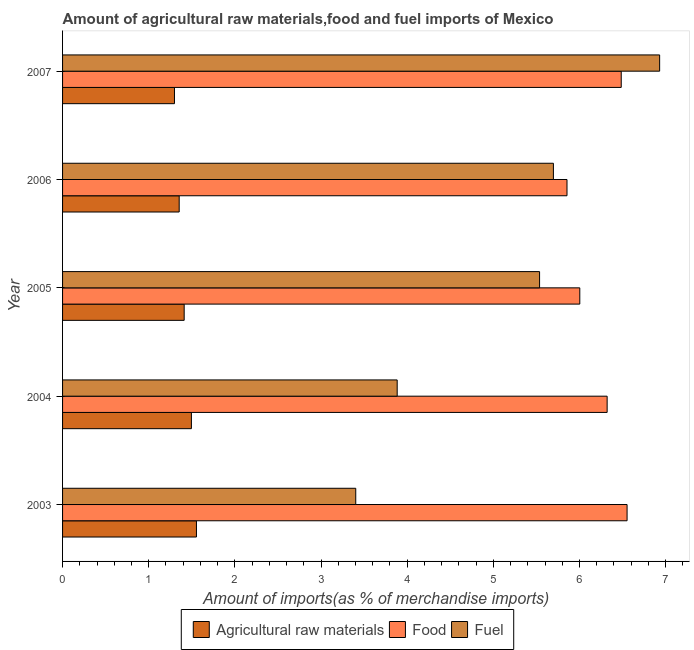How many different coloured bars are there?
Provide a succinct answer. 3. Are the number of bars per tick equal to the number of legend labels?
Provide a short and direct response. Yes. Are the number of bars on each tick of the Y-axis equal?
Give a very brief answer. Yes. What is the label of the 3rd group of bars from the top?
Your response must be concise. 2005. What is the percentage of raw materials imports in 2006?
Provide a succinct answer. 1.35. Across all years, what is the maximum percentage of food imports?
Provide a succinct answer. 6.55. Across all years, what is the minimum percentage of raw materials imports?
Offer a very short reply. 1.3. In which year was the percentage of food imports minimum?
Keep it short and to the point. 2006. What is the total percentage of raw materials imports in the graph?
Your response must be concise. 7.11. What is the difference between the percentage of food imports in 2003 and that in 2006?
Keep it short and to the point. 0.7. What is the difference between the percentage of fuel imports in 2003 and the percentage of food imports in 2005?
Make the answer very short. -2.6. What is the average percentage of raw materials imports per year?
Ensure brevity in your answer.  1.42. In the year 2004, what is the difference between the percentage of fuel imports and percentage of food imports?
Provide a short and direct response. -2.44. What is the ratio of the percentage of fuel imports in 2006 to that in 2007?
Your answer should be very brief. 0.82. Is the percentage of food imports in 2004 less than that in 2006?
Provide a succinct answer. No. Is the difference between the percentage of raw materials imports in 2004 and 2005 greater than the difference between the percentage of fuel imports in 2004 and 2005?
Your response must be concise. Yes. What is the difference between the highest and the second highest percentage of food imports?
Make the answer very short. 0.07. What is the difference between the highest and the lowest percentage of raw materials imports?
Make the answer very short. 0.26. In how many years, is the percentage of fuel imports greater than the average percentage of fuel imports taken over all years?
Your answer should be very brief. 3. Is the sum of the percentage of raw materials imports in 2003 and 2007 greater than the maximum percentage of food imports across all years?
Your answer should be very brief. No. What does the 3rd bar from the top in 2007 represents?
Provide a short and direct response. Agricultural raw materials. What does the 3rd bar from the bottom in 2004 represents?
Provide a short and direct response. Fuel. Are all the bars in the graph horizontal?
Keep it short and to the point. Yes. How many years are there in the graph?
Provide a succinct answer. 5. Does the graph contain any zero values?
Make the answer very short. No. Does the graph contain grids?
Provide a succinct answer. No. How many legend labels are there?
Your answer should be very brief. 3. How are the legend labels stacked?
Make the answer very short. Horizontal. What is the title of the graph?
Provide a succinct answer. Amount of agricultural raw materials,food and fuel imports of Mexico. What is the label or title of the X-axis?
Offer a very short reply. Amount of imports(as % of merchandise imports). What is the Amount of imports(as % of merchandise imports) in Agricultural raw materials in 2003?
Ensure brevity in your answer.  1.55. What is the Amount of imports(as % of merchandise imports) of Food in 2003?
Offer a very short reply. 6.55. What is the Amount of imports(as % of merchandise imports) of Fuel in 2003?
Provide a short and direct response. 3.4. What is the Amount of imports(as % of merchandise imports) in Agricultural raw materials in 2004?
Ensure brevity in your answer.  1.5. What is the Amount of imports(as % of merchandise imports) of Food in 2004?
Make the answer very short. 6.32. What is the Amount of imports(as % of merchandise imports) of Fuel in 2004?
Your answer should be very brief. 3.88. What is the Amount of imports(as % of merchandise imports) in Agricultural raw materials in 2005?
Ensure brevity in your answer.  1.41. What is the Amount of imports(as % of merchandise imports) of Food in 2005?
Keep it short and to the point. 6. What is the Amount of imports(as % of merchandise imports) of Fuel in 2005?
Your response must be concise. 5.54. What is the Amount of imports(as % of merchandise imports) of Agricultural raw materials in 2006?
Give a very brief answer. 1.35. What is the Amount of imports(as % of merchandise imports) in Food in 2006?
Ensure brevity in your answer.  5.86. What is the Amount of imports(as % of merchandise imports) in Fuel in 2006?
Provide a short and direct response. 5.7. What is the Amount of imports(as % of merchandise imports) in Agricultural raw materials in 2007?
Your answer should be very brief. 1.3. What is the Amount of imports(as % of merchandise imports) of Food in 2007?
Provide a short and direct response. 6.48. What is the Amount of imports(as % of merchandise imports) of Fuel in 2007?
Give a very brief answer. 6.93. Across all years, what is the maximum Amount of imports(as % of merchandise imports) of Agricultural raw materials?
Your answer should be very brief. 1.55. Across all years, what is the maximum Amount of imports(as % of merchandise imports) in Food?
Ensure brevity in your answer.  6.55. Across all years, what is the maximum Amount of imports(as % of merchandise imports) in Fuel?
Provide a succinct answer. 6.93. Across all years, what is the minimum Amount of imports(as % of merchandise imports) in Agricultural raw materials?
Provide a succinct answer. 1.3. Across all years, what is the minimum Amount of imports(as % of merchandise imports) of Food?
Provide a succinct answer. 5.86. Across all years, what is the minimum Amount of imports(as % of merchandise imports) of Fuel?
Your response must be concise. 3.4. What is the total Amount of imports(as % of merchandise imports) in Agricultural raw materials in the graph?
Give a very brief answer. 7.11. What is the total Amount of imports(as % of merchandise imports) of Food in the graph?
Your answer should be very brief. 31.22. What is the total Amount of imports(as % of merchandise imports) in Fuel in the graph?
Give a very brief answer. 25.45. What is the difference between the Amount of imports(as % of merchandise imports) of Agricultural raw materials in 2003 and that in 2004?
Your response must be concise. 0.06. What is the difference between the Amount of imports(as % of merchandise imports) of Food in 2003 and that in 2004?
Provide a succinct answer. 0.23. What is the difference between the Amount of imports(as % of merchandise imports) of Fuel in 2003 and that in 2004?
Offer a terse response. -0.48. What is the difference between the Amount of imports(as % of merchandise imports) in Agricultural raw materials in 2003 and that in 2005?
Your response must be concise. 0.14. What is the difference between the Amount of imports(as % of merchandise imports) in Food in 2003 and that in 2005?
Provide a succinct answer. 0.55. What is the difference between the Amount of imports(as % of merchandise imports) in Fuel in 2003 and that in 2005?
Your response must be concise. -2.13. What is the difference between the Amount of imports(as % of merchandise imports) in Agricultural raw materials in 2003 and that in 2006?
Give a very brief answer. 0.2. What is the difference between the Amount of imports(as % of merchandise imports) in Food in 2003 and that in 2006?
Make the answer very short. 0.7. What is the difference between the Amount of imports(as % of merchandise imports) of Fuel in 2003 and that in 2006?
Provide a short and direct response. -2.29. What is the difference between the Amount of imports(as % of merchandise imports) in Agricultural raw materials in 2003 and that in 2007?
Ensure brevity in your answer.  0.26. What is the difference between the Amount of imports(as % of merchandise imports) of Food in 2003 and that in 2007?
Your answer should be compact. 0.07. What is the difference between the Amount of imports(as % of merchandise imports) of Fuel in 2003 and that in 2007?
Keep it short and to the point. -3.53. What is the difference between the Amount of imports(as % of merchandise imports) of Agricultural raw materials in 2004 and that in 2005?
Your answer should be compact. 0.08. What is the difference between the Amount of imports(as % of merchandise imports) in Food in 2004 and that in 2005?
Offer a terse response. 0.32. What is the difference between the Amount of imports(as % of merchandise imports) of Fuel in 2004 and that in 2005?
Make the answer very short. -1.65. What is the difference between the Amount of imports(as % of merchandise imports) of Agricultural raw materials in 2004 and that in 2006?
Give a very brief answer. 0.14. What is the difference between the Amount of imports(as % of merchandise imports) in Food in 2004 and that in 2006?
Your response must be concise. 0.47. What is the difference between the Amount of imports(as % of merchandise imports) in Fuel in 2004 and that in 2006?
Give a very brief answer. -1.81. What is the difference between the Amount of imports(as % of merchandise imports) in Agricultural raw materials in 2004 and that in 2007?
Offer a terse response. 0.2. What is the difference between the Amount of imports(as % of merchandise imports) in Food in 2004 and that in 2007?
Ensure brevity in your answer.  -0.16. What is the difference between the Amount of imports(as % of merchandise imports) in Fuel in 2004 and that in 2007?
Your answer should be compact. -3.05. What is the difference between the Amount of imports(as % of merchandise imports) of Agricultural raw materials in 2005 and that in 2006?
Ensure brevity in your answer.  0.06. What is the difference between the Amount of imports(as % of merchandise imports) of Food in 2005 and that in 2006?
Provide a succinct answer. 0.15. What is the difference between the Amount of imports(as % of merchandise imports) of Fuel in 2005 and that in 2006?
Offer a terse response. -0.16. What is the difference between the Amount of imports(as % of merchandise imports) of Agricultural raw materials in 2005 and that in 2007?
Ensure brevity in your answer.  0.11. What is the difference between the Amount of imports(as % of merchandise imports) of Food in 2005 and that in 2007?
Your answer should be very brief. -0.48. What is the difference between the Amount of imports(as % of merchandise imports) in Fuel in 2005 and that in 2007?
Offer a terse response. -1.39. What is the difference between the Amount of imports(as % of merchandise imports) of Agricultural raw materials in 2006 and that in 2007?
Offer a very short reply. 0.05. What is the difference between the Amount of imports(as % of merchandise imports) in Food in 2006 and that in 2007?
Keep it short and to the point. -0.63. What is the difference between the Amount of imports(as % of merchandise imports) in Fuel in 2006 and that in 2007?
Provide a short and direct response. -1.23. What is the difference between the Amount of imports(as % of merchandise imports) in Agricultural raw materials in 2003 and the Amount of imports(as % of merchandise imports) in Food in 2004?
Your answer should be compact. -4.77. What is the difference between the Amount of imports(as % of merchandise imports) in Agricultural raw materials in 2003 and the Amount of imports(as % of merchandise imports) in Fuel in 2004?
Make the answer very short. -2.33. What is the difference between the Amount of imports(as % of merchandise imports) of Food in 2003 and the Amount of imports(as % of merchandise imports) of Fuel in 2004?
Your answer should be very brief. 2.67. What is the difference between the Amount of imports(as % of merchandise imports) in Agricultural raw materials in 2003 and the Amount of imports(as % of merchandise imports) in Food in 2005?
Provide a succinct answer. -4.45. What is the difference between the Amount of imports(as % of merchandise imports) in Agricultural raw materials in 2003 and the Amount of imports(as % of merchandise imports) in Fuel in 2005?
Offer a terse response. -3.98. What is the difference between the Amount of imports(as % of merchandise imports) of Food in 2003 and the Amount of imports(as % of merchandise imports) of Fuel in 2005?
Keep it short and to the point. 1.02. What is the difference between the Amount of imports(as % of merchandise imports) in Agricultural raw materials in 2003 and the Amount of imports(as % of merchandise imports) in Food in 2006?
Keep it short and to the point. -4.3. What is the difference between the Amount of imports(as % of merchandise imports) in Agricultural raw materials in 2003 and the Amount of imports(as % of merchandise imports) in Fuel in 2006?
Provide a short and direct response. -4.14. What is the difference between the Amount of imports(as % of merchandise imports) in Food in 2003 and the Amount of imports(as % of merchandise imports) in Fuel in 2006?
Provide a succinct answer. 0.86. What is the difference between the Amount of imports(as % of merchandise imports) of Agricultural raw materials in 2003 and the Amount of imports(as % of merchandise imports) of Food in 2007?
Your response must be concise. -4.93. What is the difference between the Amount of imports(as % of merchandise imports) of Agricultural raw materials in 2003 and the Amount of imports(as % of merchandise imports) of Fuel in 2007?
Provide a succinct answer. -5.38. What is the difference between the Amount of imports(as % of merchandise imports) in Food in 2003 and the Amount of imports(as % of merchandise imports) in Fuel in 2007?
Provide a succinct answer. -0.38. What is the difference between the Amount of imports(as % of merchandise imports) of Agricultural raw materials in 2004 and the Amount of imports(as % of merchandise imports) of Food in 2005?
Offer a terse response. -4.51. What is the difference between the Amount of imports(as % of merchandise imports) in Agricultural raw materials in 2004 and the Amount of imports(as % of merchandise imports) in Fuel in 2005?
Provide a short and direct response. -4.04. What is the difference between the Amount of imports(as % of merchandise imports) in Food in 2004 and the Amount of imports(as % of merchandise imports) in Fuel in 2005?
Give a very brief answer. 0.78. What is the difference between the Amount of imports(as % of merchandise imports) in Agricultural raw materials in 2004 and the Amount of imports(as % of merchandise imports) in Food in 2006?
Your answer should be very brief. -4.36. What is the difference between the Amount of imports(as % of merchandise imports) in Agricultural raw materials in 2004 and the Amount of imports(as % of merchandise imports) in Fuel in 2006?
Offer a very short reply. -4.2. What is the difference between the Amount of imports(as % of merchandise imports) in Food in 2004 and the Amount of imports(as % of merchandise imports) in Fuel in 2006?
Your response must be concise. 0.62. What is the difference between the Amount of imports(as % of merchandise imports) of Agricultural raw materials in 2004 and the Amount of imports(as % of merchandise imports) of Food in 2007?
Keep it short and to the point. -4.99. What is the difference between the Amount of imports(as % of merchandise imports) in Agricultural raw materials in 2004 and the Amount of imports(as % of merchandise imports) in Fuel in 2007?
Give a very brief answer. -5.44. What is the difference between the Amount of imports(as % of merchandise imports) in Food in 2004 and the Amount of imports(as % of merchandise imports) in Fuel in 2007?
Your response must be concise. -0.61. What is the difference between the Amount of imports(as % of merchandise imports) in Agricultural raw materials in 2005 and the Amount of imports(as % of merchandise imports) in Food in 2006?
Your answer should be very brief. -4.44. What is the difference between the Amount of imports(as % of merchandise imports) of Agricultural raw materials in 2005 and the Amount of imports(as % of merchandise imports) of Fuel in 2006?
Your answer should be very brief. -4.29. What is the difference between the Amount of imports(as % of merchandise imports) in Food in 2005 and the Amount of imports(as % of merchandise imports) in Fuel in 2006?
Offer a terse response. 0.31. What is the difference between the Amount of imports(as % of merchandise imports) of Agricultural raw materials in 2005 and the Amount of imports(as % of merchandise imports) of Food in 2007?
Your response must be concise. -5.07. What is the difference between the Amount of imports(as % of merchandise imports) of Agricultural raw materials in 2005 and the Amount of imports(as % of merchandise imports) of Fuel in 2007?
Provide a short and direct response. -5.52. What is the difference between the Amount of imports(as % of merchandise imports) of Food in 2005 and the Amount of imports(as % of merchandise imports) of Fuel in 2007?
Provide a short and direct response. -0.93. What is the difference between the Amount of imports(as % of merchandise imports) in Agricultural raw materials in 2006 and the Amount of imports(as % of merchandise imports) in Food in 2007?
Your response must be concise. -5.13. What is the difference between the Amount of imports(as % of merchandise imports) of Agricultural raw materials in 2006 and the Amount of imports(as % of merchandise imports) of Fuel in 2007?
Your answer should be very brief. -5.58. What is the difference between the Amount of imports(as % of merchandise imports) in Food in 2006 and the Amount of imports(as % of merchandise imports) in Fuel in 2007?
Provide a succinct answer. -1.08. What is the average Amount of imports(as % of merchandise imports) of Agricultural raw materials per year?
Your response must be concise. 1.42. What is the average Amount of imports(as % of merchandise imports) of Food per year?
Offer a terse response. 6.24. What is the average Amount of imports(as % of merchandise imports) in Fuel per year?
Your answer should be compact. 5.09. In the year 2003, what is the difference between the Amount of imports(as % of merchandise imports) of Agricultural raw materials and Amount of imports(as % of merchandise imports) of Food?
Provide a succinct answer. -5. In the year 2003, what is the difference between the Amount of imports(as % of merchandise imports) of Agricultural raw materials and Amount of imports(as % of merchandise imports) of Fuel?
Provide a succinct answer. -1.85. In the year 2003, what is the difference between the Amount of imports(as % of merchandise imports) in Food and Amount of imports(as % of merchandise imports) in Fuel?
Your answer should be compact. 3.15. In the year 2004, what is the difference between the Amount of imports(as % of merchandise imports) of Agricultural raw materials and Amount of imports(as % of merchandise imports) of Food?
Offer a terse response. -4.83. In the year 2004, what is the difference between the Amount of imports(as % of merchandise imports) in Agricultural raw materials and Amount of imports(as % of merchandise imports) in Fuel?
Offer a very short reply. -2.39. In the year 2004, what is the difference between the Amount of imports(as % of merchandise imports) in Food and Amount of imports(as % of merchandise imports) in Fuel?
Provide a short and direct response. 2.44. In the year 2005, what is the difference between the Amount of imports(as % of merchandise imports) in Agricultural raw materials and Amount of imports(as % of merchandise imports) in Food?
Your response must be concise. -4.59. In the year 2005, what is the difference between the Amount of imports(as % of merchandise imports) in Agricultural raw materials and Amount of imports(as % of merchandise imports) in Fuel?
Give a very brief answer. -4.13. In the year 2005, what is the difference between the Amount of imports(as % of merchandise imports) in Food and Amount of imports(as % of merchandise imports) in Fuel?
Keep it short and to the point. 0.47. In the year 2006, what is the difference between the Amount of imports(as % of merchandise imports) in Agricultural raw materials and Amount of imports(as % of merchandise imports) in Food?
Offer a very short reply. -4.5. In the year 2006, what is the difference between the Amount of imports(as % of merchandise imports) in Agricultural raw materials and Amount of imports(as % of merchandise imports) in Fuel?
Make the answer very short. -4.34. In the year 2006, what is the difference between the Amount of imports(as % of merchandise imports) of Food and Amount of imports(as % of merchandise imports) of Fuel?
Your answer should be very brief. 0.16. In the year 2007, what is the difference between the Amount of imports(as % of merchandise imports) of Agricultural raw materials and Amount of imports(as % of merchandise imports) of Food?
Your response must be concise. -5.19. In the year 2007, what is the difference between the Amount of imports(as % of merchandise imports) of Agricultural raw materials and Amount of imports(as % of merchandise imports) of Fuel?
Make the answer very short. -5.63. In the year 2007, what is the difference between the Amount of imports(as % of merchandise imports) of Food and Amount of imports(as % of merchandise imports) of Fuel?
Your response must be concise. -0.45. What is the ratio of the Amount of imports(as % of merchandise imports) in Agricultural raw materials in 2003 to that in 2004?
Ensure brevity in your answer.  1.04. What is the ratio of the Amount of imports(as % of merchandise imports) in Food in 2003 to that in 2004?
Give a very brief answer. 1.04. What is the ratio of the Amount of imports(as % of merchandise imports) of Fuel in 2003 to that in 2004?
Keep it short and to the point. 0.88. What is the ratio of the Amount of imports(as % of merchandise imports) of Agricultural raw materials in 2003 to that in 2005?
Offer a terse response. 1.1. What is the ratio of the Amount of imports(as % of merchandise imports) of Food in 2003 to that in 2005?
Your response must be concise. 1.09. What is the ratio of the Amount of imports(as % of merchandise imports) in Fuel in 2003 to that in 2005?
Provide a short and direct response. 0.61. What is the ratio of the Amount of imports(as % of merchandise imports) of Agricultural raw materials in 2003 to that in 2006?
Make the answer very short. 1.15. What is the ratio of the Amount of imports(as % of merchandise imports) of Food in 2003 to that in 2006?
Offer a terse response. 1.12. What is the ratio of the Amount of imports(as % of merchandise imports) of Fuel in 2003 to that in 2006?
Your answer should be very brief. 0.6. What is the ratio of the Amount of imports(as % of merchandise imports) of Agricultural raw materials in 2003 to that in 2007?
Ensure brevity in your answer.  1.2. What is the ratio of the Amount of imports(as % of merchandise imports) of Food in 2003 to that in 2007?
Offer a very short reply. 1.01. What is the ratio of the Amount of imports(as % of merchandise imports) in Fuel in 2003 to that in 2007?
Make the answer very short. 0.49. What is the ratio of the Amount of imports(as % of merchandise imports) of Agricultural raw materials in 2004 to that in 2005?
Give a very brief answer. 1.06. What is the ratio of the Amount of imports(as % of merchandise imports) in Food in 2004 to that in 2005?
Offer a very short reply. 1.05. What is the ratio of the Amount of imports(as % of merchandise imports) of Fuel in 2004 to that in 2005?
Your answer should be compact. 0.7. What is the ratio of the Amount of imports(as % of merchandise imports) in Agricultural raw materials in 2004 to that in 2006?
Offer a very short reply. 1.1. What is the ratio of the Amount of imports(as % of merchandise imports) in Food in 2004 to that in 2006?
Make the answer very short. 1.08. What is the ratio of the Amount of imports(as % of merchandise imports) of Fuel in 2004 to that in 2006?
Ensure brevity in your answer.  0.68. What is the ratio of the Amount of imports(as % of merchandise imports) of Agricultural raw materials in 2004 to that in 2007?
Offer a terse response. 1.15. What is the ratio of the Amount of imports(as % of merchandise imports) of Food in 2004 to that in 2007?
Your answer should be very brief. 0.97. What is the ratio of the Amount of imports(as % of merchandise imports) in Fuel in 2004 to that in 2007?
Your answer should be compact. 0.56. What is the ratio of the Amount of imports(as % of merchandise imports) in Agricultural raw materials in 2005 to that in 2006?
Your response must be concise. 1.04. What is the ratio of the Amount of imports(as % of merchandise imports) of Food in 2005 to that in 2006?
Provide a short and direct response. 1.03. What is the ratio of the Amount of imports(as % of merchandise imports) of Fuel in 2005 to that in 2006?
Offer a terse response. 0.97. What is the ratio of the Amount of imports(as % of merchandise imports) of Agricultural raw materials in 2005 to that in 2007?
Your answer should be compact. 1.09. What is the ratio of the Amount of imports(as % of merchandise imports) in Food in 2005 to that in 2007?
Provide a short and direct response. 0.93. What is the ratio of the Amount of imports(as % of merchandise imports) of Fuel in 2005 to that in 2007?
Make the answer very short. 0.8. What is the ratio of the Amount of imports(as % of merchandise imports) in Agricultural raw materials in 2006 to that in 2007?
Keep it short and to the point. 1.04. What is the ratio of the Amount of imports(as % of merchandise imports) of Food in 2006 to that in 2007?
Provide a short and direct response. 0.9. What is the ratio of the Amount of imports(as % of merchandise imports) of Fuel in 2006 to that in 2007?
Provide a succinct answer. 0.82. What is the difference between the highest and the second highest Amount of imports(as % of merchandise imports) of Agricultural raw materials?
Provide a short and direct response. 0.06. What is the difference between the highest and the second highest Amount of imports(as % of merchandise imports) in Food?
Give a very brief answer. 0.07. What is the difference between the highest and the second highest Amount of imports(as % of merchandise imports) of Fuel?
Your answer should be compact. 1.23. What is the difference between the highest and the lowest Amount of imports(as % of merchandise imports) in Agricultural raw materials?
Make the answer very short. 0.26. What is the difference between the highest and the lowest Amount of imports(as % of merchandise imports) in Food?
Provide a short and direct response. 0.7. What is the difference between the highest and the lowest Amount of imports(as % of merchandise imports) of Fuel?
Your answer should be very brief. 3.53. 